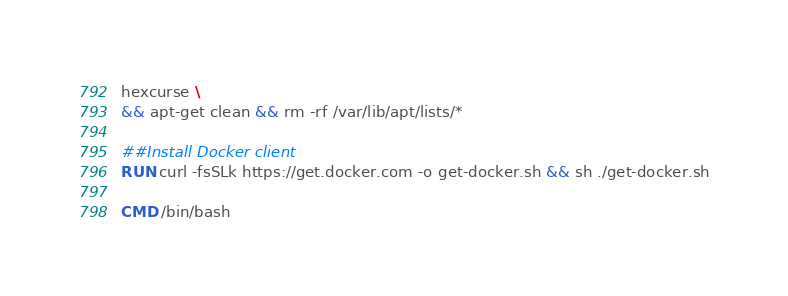<code> <loc_0><loc_0><loc_500><loc_500><_Dockerfile_>hexcurse \
&& apt-get clean && rm -rf /var/lib/apt/lists/*

##Install Docker client
RUN curl -fsSLk https://get.docker.com -o get-docker.sh && sh ./get-docker.sh

CMD /bin/bash

</code> 